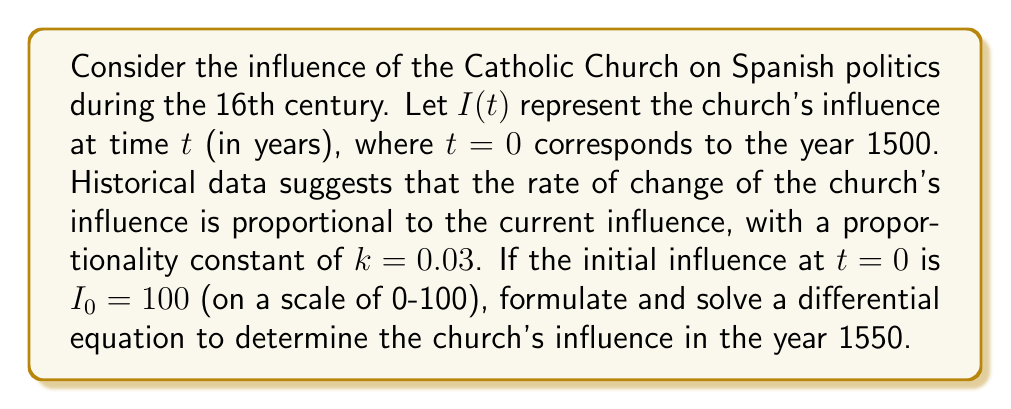Give your solution to this math problem. 1. Formulate the differential equation:
   The rate of change of influence is proportional to the current influence:
   $$\frac{dI}{dt} = kI$$
   where $k=0.03$ and $I(0) = 100$

2. Separate variables:
   $$\frac{dI}{I} = k dt$$

3. Integrate both sides:
   $$\int \frac{dI}{I} = \int k dt$$
   $$\ln|I| = kt + C$$

4. Solve for $I$:
   $$I = e^{kt + C} = e^C \cdot e^{kt}$$

5. Use the initial condition to find $e^C$:
   At $t=0$, $I(0) = 100 = e^C \cdot e^{k\cdot0} = e^C$
   Therefore, $e^C = 100$

6. Write the general solution:
   $$I(t) = 100 \cdot e^{0.03t}$$

7. Calculate the influence at $t=50$ (year 1550):
   $$I(50) = 100 \cdot e^{0.03 \cdot 50} \approx 448.17$$
Answer: 448.17 